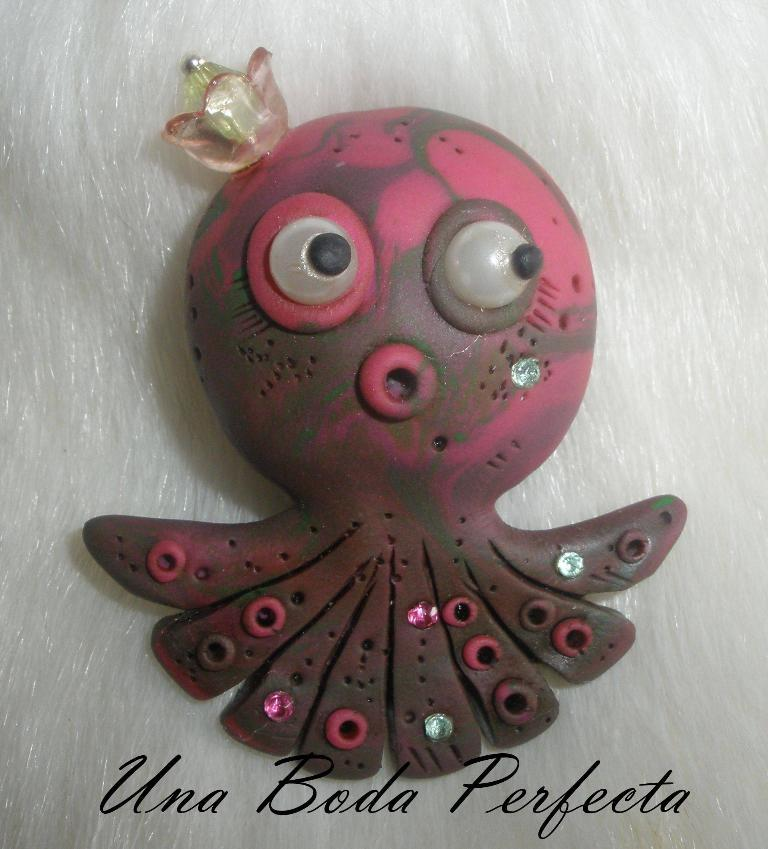What is the main object in the image? There is a toy in the image. What colors can be seen on the toy? The toy has pink and brown colors. What color is the background of the image? The background of the image is white. What is the tendency of the toy to make noise in the image? There is no information about the toy's tendency to make noise in the image. Can you see any toes on the toy in the image? There is no mention of toes or any body parts on the toy in the image. 